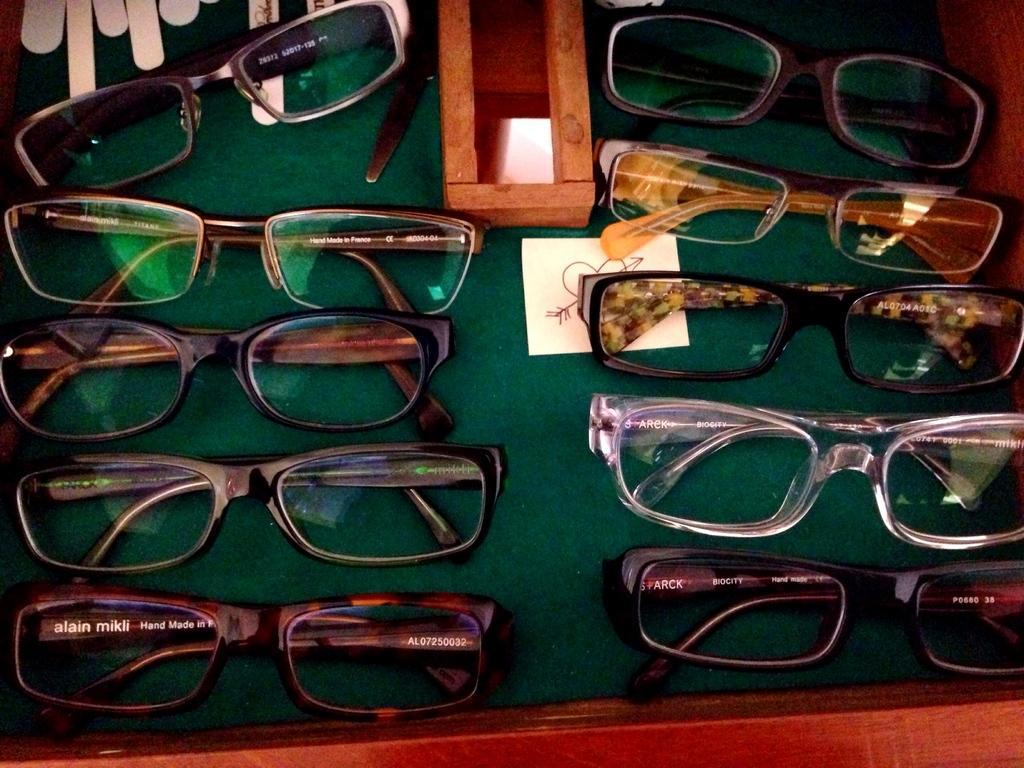What type of furniture is visible in the image? There are tables in the image. What objects are on the tables in the image? There are spectacles on the table. Can you see anyone experiencing pain in the image? There is no indication of pain in the image; it only shows tables and spectacles. 